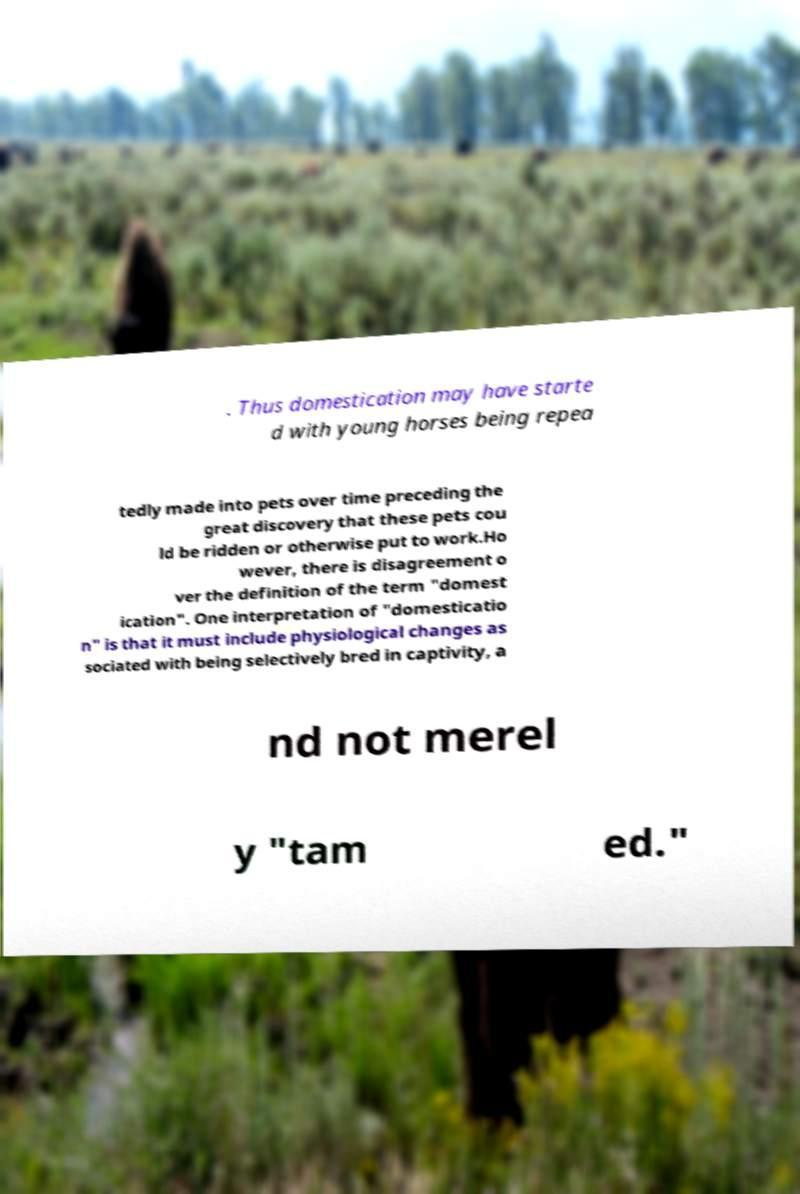Could you assist in decoding the text presented in this image and type it out clearly? . Thus domestication may have starte d with young horses being repea tedly made into pets over time preceding the great discovery that these pets cou ld be ridden or otherwise put to work.Ho wever, there is disagreement o ver the definition of the term "domest ication". One interpretation of "domesticatio n" is that it must include physiological changes as sociated with being selectively bred in captivity, a nd not merel y "tam ed." 